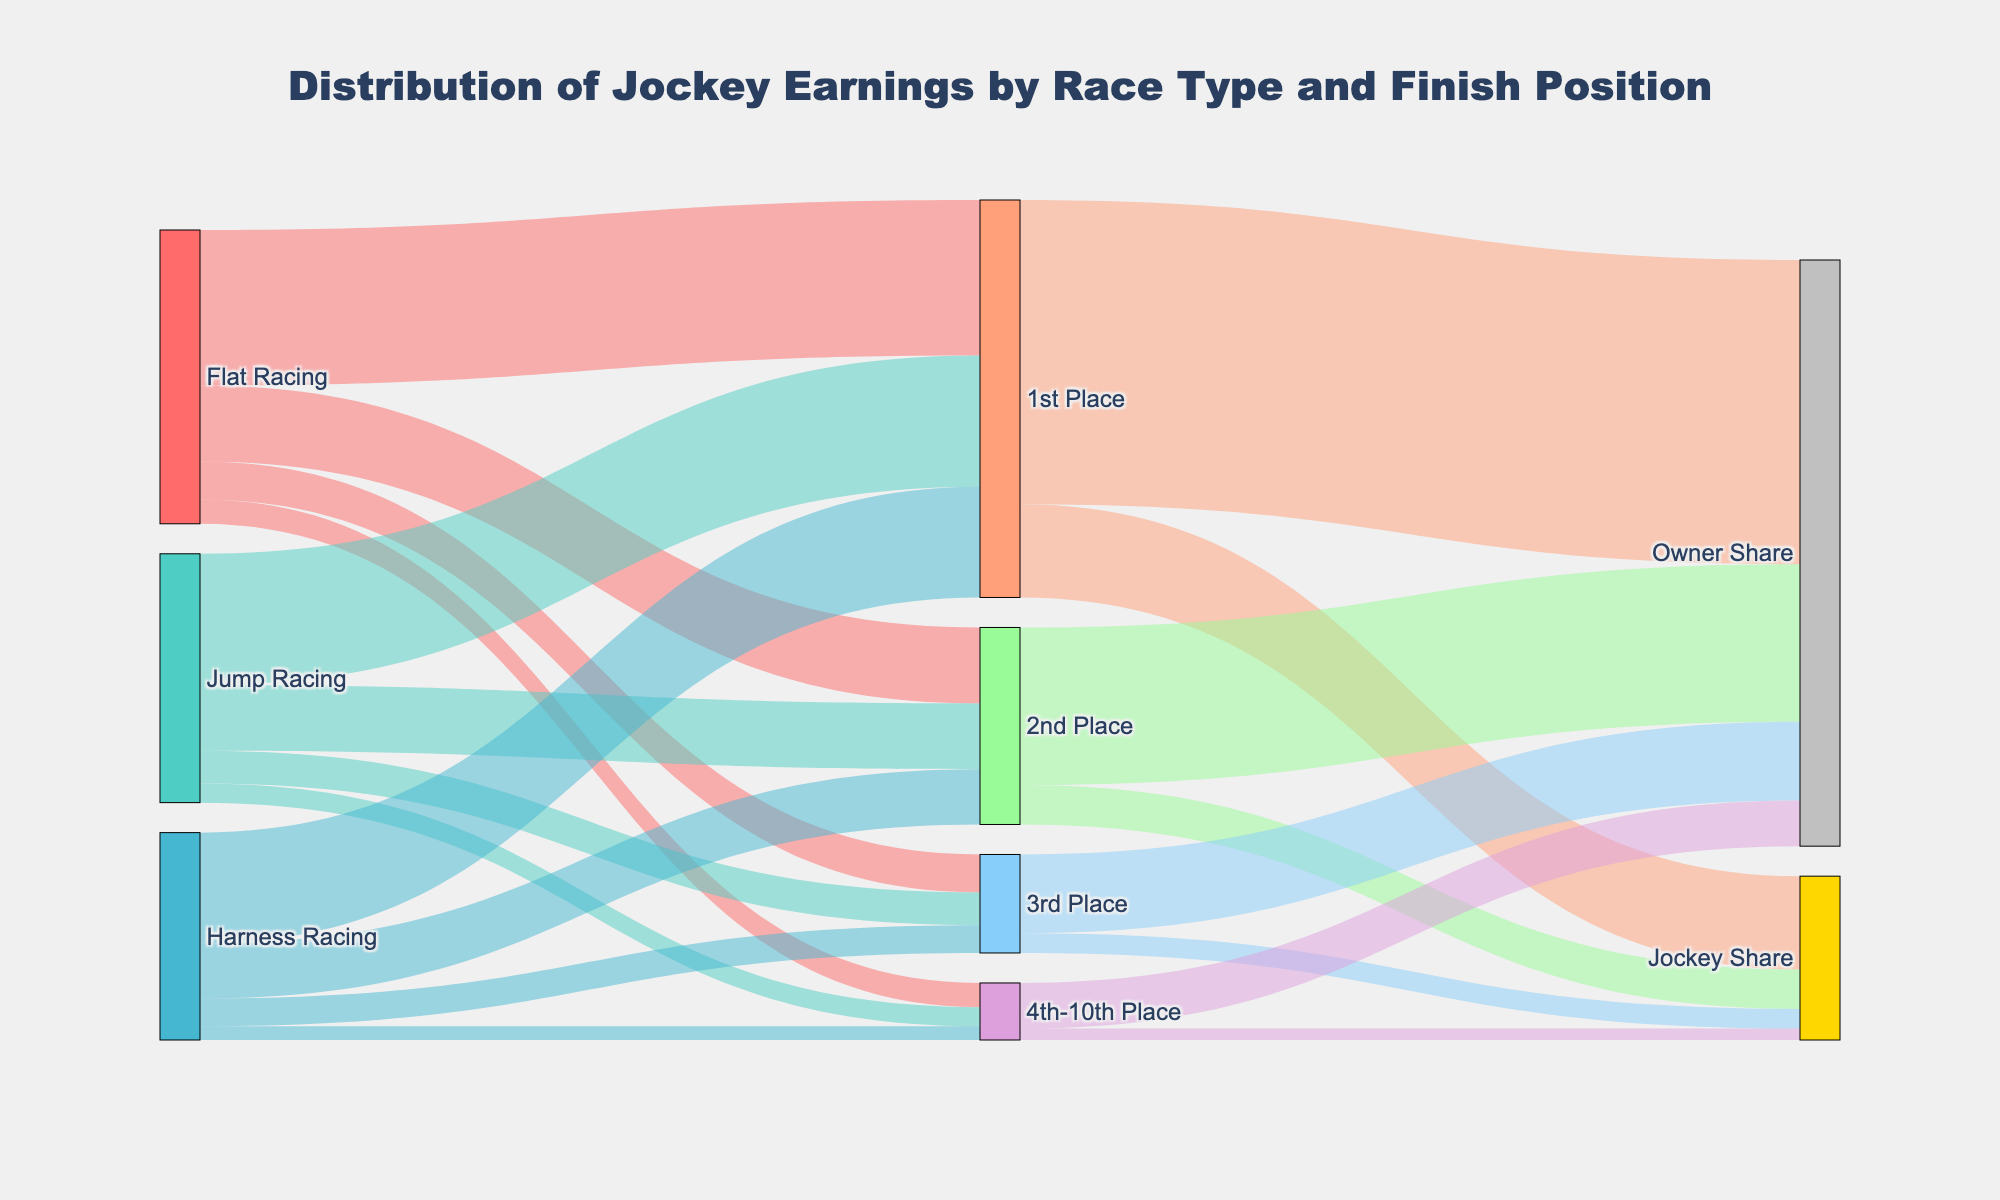How much do jockeys earn from 1st place in Flat Racing? The figure shows that 1st place in Flat Racing provides earnings distributed into jockey share and owner share. The earnings for 1st place in Flat Racing are 45000.
Answer: 45000 Which race type contributes the most to jockey earnings for 2nd place? By comparing the links leading to 2nd place, we observe that Flat Racing contributes 22000, Jump Racing contributes 19000, and Harness Racing contributes 16000. Therefore, Flat Racing contributes the most for 2nd place.
Answer: Flat Racing What is the total amount earned from 4th-10th place across all race types? Summing up the values from 4th-10th Place for Flat Racing (7000), Jump Racing (5500), and Harness Racing (4000), we get a total of 7000 + 5500 + 4000 = 16500.
Answer: 16500 How does the jockey's share compare between 1st place and 3rd place? The earnings for the jockey's share in 1st place are 27000, whereas for 3rd place, it is 5700. To compare, 27000 is significantly higher than 5700.
Answer: 1st place is significantly higher Which component has the highest individual earnings contribution, and what is that value? The figure shows the different earnings values, and the highest individual earnings contribution is from 'Owner Share' following '1st Place' with a value of 88000.
Answer: Owner Share from 1st Place with 88000 What are the total earnings for jockeys from all finish positions combined? By adding the jockey shares from 1st place (27000), 2nd place (11400), 3rd place (5700), and 4th-10th places (3300), we get a total of 27000 + 11400 + 5700 + 3300 = 47400.
Answer: 47400 In which race type do jockeys earn the least from 1st place finishes? Comparing 1st place earnings across race types, Flat Racing makes 45000, Jump Racing 38000, and Harness Racing 32000. Thus, jockeys earn the least from 1st place in Harness Racing.
Answer: Harness Racing What is the ratio of the jockey's share to the owner's share for 2nd place finishes? For 2nd place, the jockey's share is 11400, and the owner's share is 45600. The ratio is calculated as 11400/45600 = 1:4.
Answer: 1:4 How do total jockey earnings from Jump Racing compare to total earnings from Harness Racing? Summing up jockey earnings from Jump Racing (38000 + 19000 + 9500 + 5500) = 72000 and Harness Racing (32000 + 16000 + 8000 + 4000) = 60000, we see that Jump Racing's total earnings are higher.
Answer: Jump Racing is higher By how much do 1st place jockey earnings in Flat Racing exceed those in Jump Racing? The 1st place jockey earnings in Flat Racing are 45000, and in Jump Racing, it is 38000. The difference is 45000 - 38000 = 7000.
Answer: 7000 